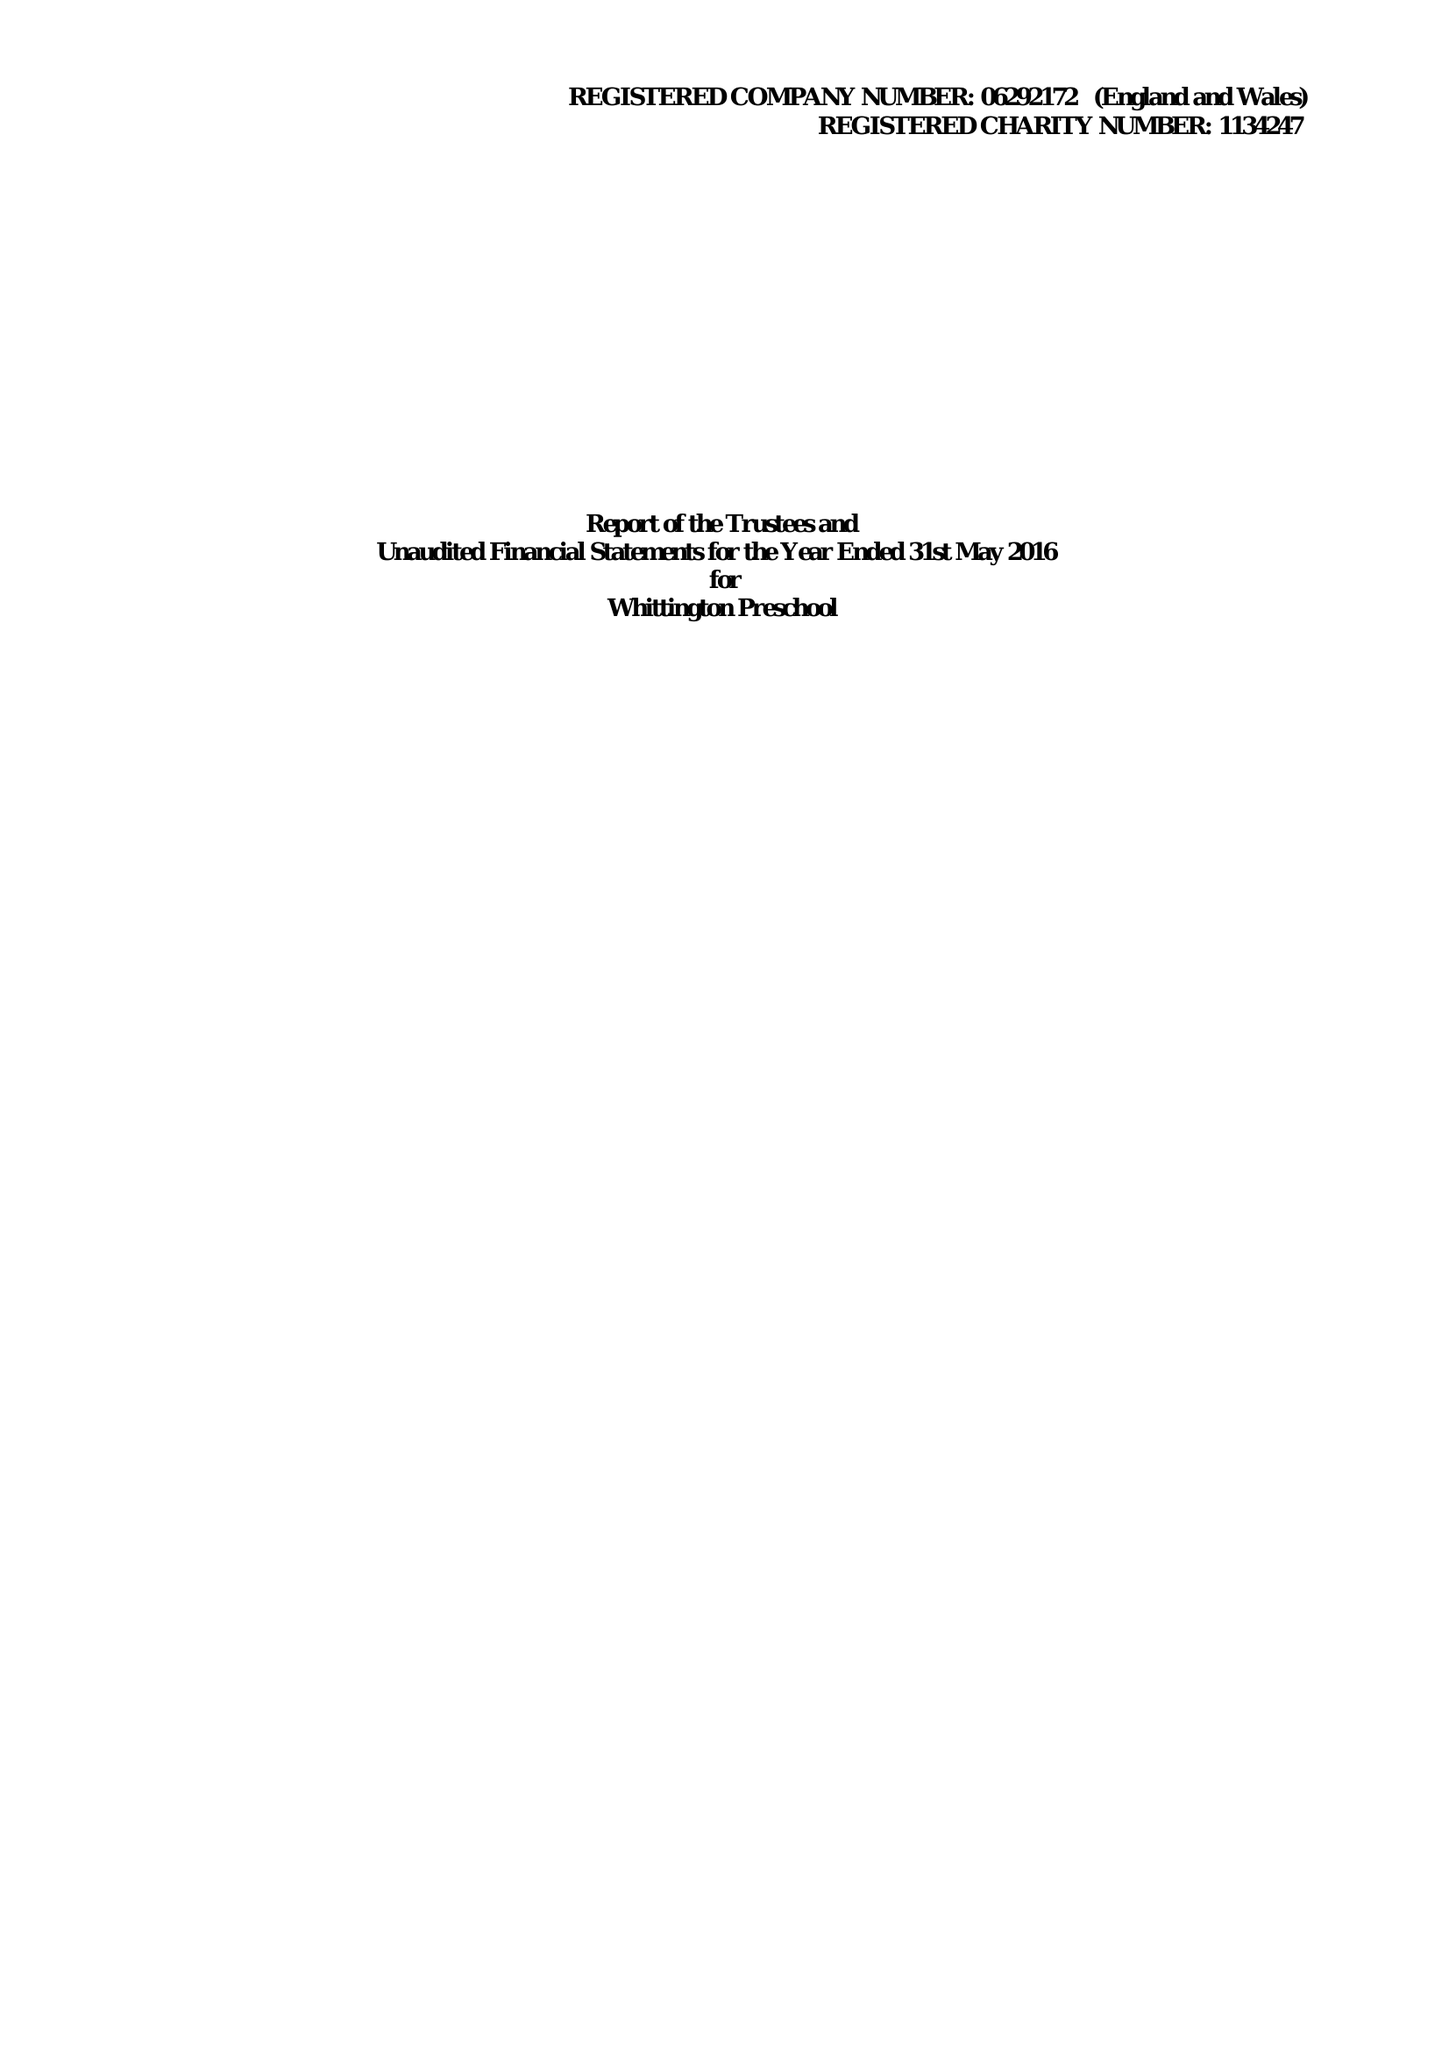What is the value for the report_date?
Answer the question using a single word or phrase. 2016-05-31 